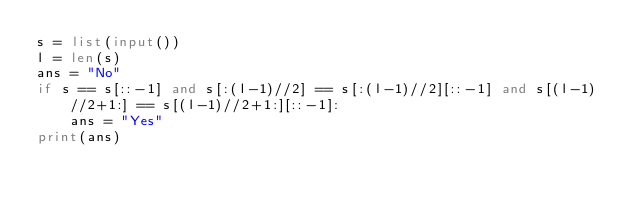Convert code to text. <code><loc_0><loc_0><loc_500><loc_500><_Python_>s = list(input())
l = len(s)
ans = "No"
if s == s[::-1] and s[:(l-1)//2] == s[:(l-1)//2][::-1] and s[(l-1)//2+1:] == s[(l-1)//2+1:][::-1]:
    ans = "Yes"
print(ans)</code> 